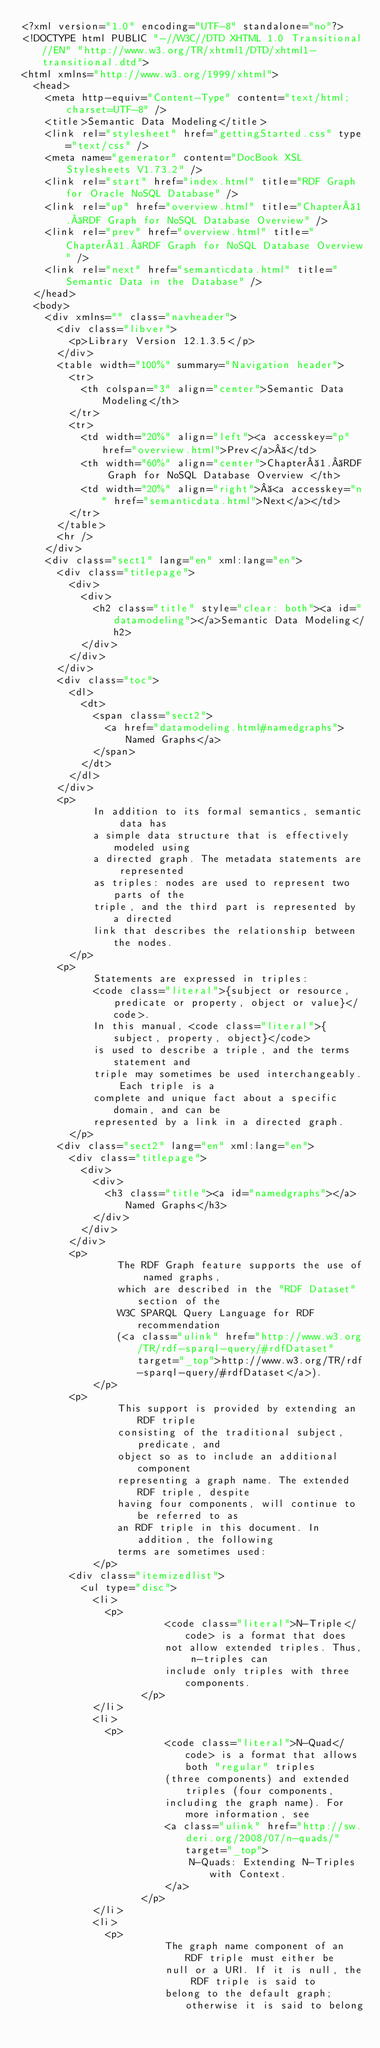<code> <loc_0><loc_0><loc_500><loc_500><_HTML_><?xml version="1.0" encoding="UTF-8" standalone="no"?>
<!DOCTYPE html PUBLIC "-//W3C//DTD XHTML 1.0 Transitional//EN" "http://www.w3.org/TR/xhtml1/DTD/xhtml1-transitional.dtd">
<html xmlns="http://www.w3.org/1999/xhtml">
  <head>
    <meta http-equiv="Content-Type" content="text/html; charset=UTF-8" />
    <title>Semantic Data Modeling</title>
    <link rel="stylesheet" href="gettingStarted.css" type="text/css" />
    <meta name="generator" content="DocBook XSL Stylesheets V1.73.2" />
    <link rel="start" href="index.html" title="RDF Graph for Oracle NoSQL Database" />
    <link rel="up" href="overview.html" title="Chapter 1. RDF Graph for NoSQL Database Overview" />
    <link rel="prev" href="overview.html" title="Chapter 1. RDF Graph for NoSQL Database Overview" />
    <link rel="next" href="semanticdata.html" title="Semantic Data in the Database" />
  </head>
  <body>
    <div xmlns="" class="navheader">
      <div class="libver">
        <p>Library Version 12.1.3.5</p>
      </div>
      <table width="100%" summary="Navigation header">
        <tr>
          <th colspan="3" align="center">Semantic Data Modeling</th>
        </tr>
        <tr>
          <td width="20%" align="left"><a accesskey="p" href="overview.html">Prev</a> </td>
          <th width="60%" align="center">Chapter 1. RDF Graph for NoSQL Database Overview </th>
          <td width="20%" align="right"> <a accesskey="n" href="semanticdata.html">Next</a></td>
        </tr>
      </table>
      <hr />
    </div>
    <div class="sect1" lang="en" xml:lang="en">
      <div class="titlepage">
        <div>
          <div>
            <h2 class="title" style="clear: both"><a id="datamodeling"></a>Semantic Data Modeling</h2>
          </div>
        </div>
      </div>
      <div class="toc">
        <dl>
          <dt>
            <span class="sect2">
              <a href="datamodeling.html#namedgraphs">Named Graphs</a>
            </span>
          </dt>
        </dl>
      </div>
      <p> 
            In addition to its formal semantics, semantic data has
            a simple data structure that is effectively modeled using
            a directed graph. The metadata statements are represented
            as triples: nodes are used to represent two parts of the
            triple, and the third part is represented by a directed
            link that describes the relationship between the nodes.
        </p>
      <p> 
            Statements are expressed in triples: 
            <code class="literal">{subject or resource, predicate or property, object or value}</code>. 
            In this manual, <code class="literal">{subject, property, object}</code> 
            is used to describe a triple, and the terms statement and
            triple may sometimes be used interchangeably. Each triple is a
            complete and unique fact about a specific domain, and can be
            represented by a link in a directed graph. 
        </p>
      <div class="sect2" lang="en" xml:lang="en">
        <div class="titlepage">
          <div>
            <div>
              <h3 class="title"><a id="namedgraphs"></a>Named Graphs</h3>
            </div>
          </div>
        </div>
        <p> 
                The RDF Graph feature supports the use of named graphs,
                which are described in the "RDF Dataset" section of the
                W3C SPARQL Query Language for RDF recommendation
                (<a class="ulink" href="http://www.w3.org/TR/rdf-sparql-query/#rdfDataset" target="_top">http://www.w3.org/TR/rdf-sparql-query/#rdfDataset</a>).
            </p>
        <p> 
                This support is provided by extending an RDF triple
                consisting of the traditional subject, predicate, and
                object so as to include an additional component
                representing a graph name. The extended RDF triple, despite
                having four components, will continue to be referred to as
                an RDF triple in this document. In addition, the following
                terms are sometimes used:
            </p>
        <div class="itemizedlist">
          <ul type="disc">
            <li>
              <p>
                        <code class="literal">N-Triple</code> is a format that does
                        not allow extended triples. Thus, n-triples can
                        include only triples with three components. 
                    </p>
            </li>
            <li>
              <p>
                        <code class="literal">N-Quad</code> is a format that allows both "regular" triples
                        (three components) and extended triples (four components,
                        including the graph name). For more information, see
                        <a class="ulink" href="http://sw.deri.org/2008/07/n-quads/" target="_top">
                            N-Quads: Extending N-Triples with Context.
                        </a>
                    </p>
            </li>
            <li>
              <p>
                        The graph name component of an RDF triple must either be
                        null or a URI. If it is null, the RDF triple is said to
                        belong to the default graph; otherwise it is said to belong</code> 